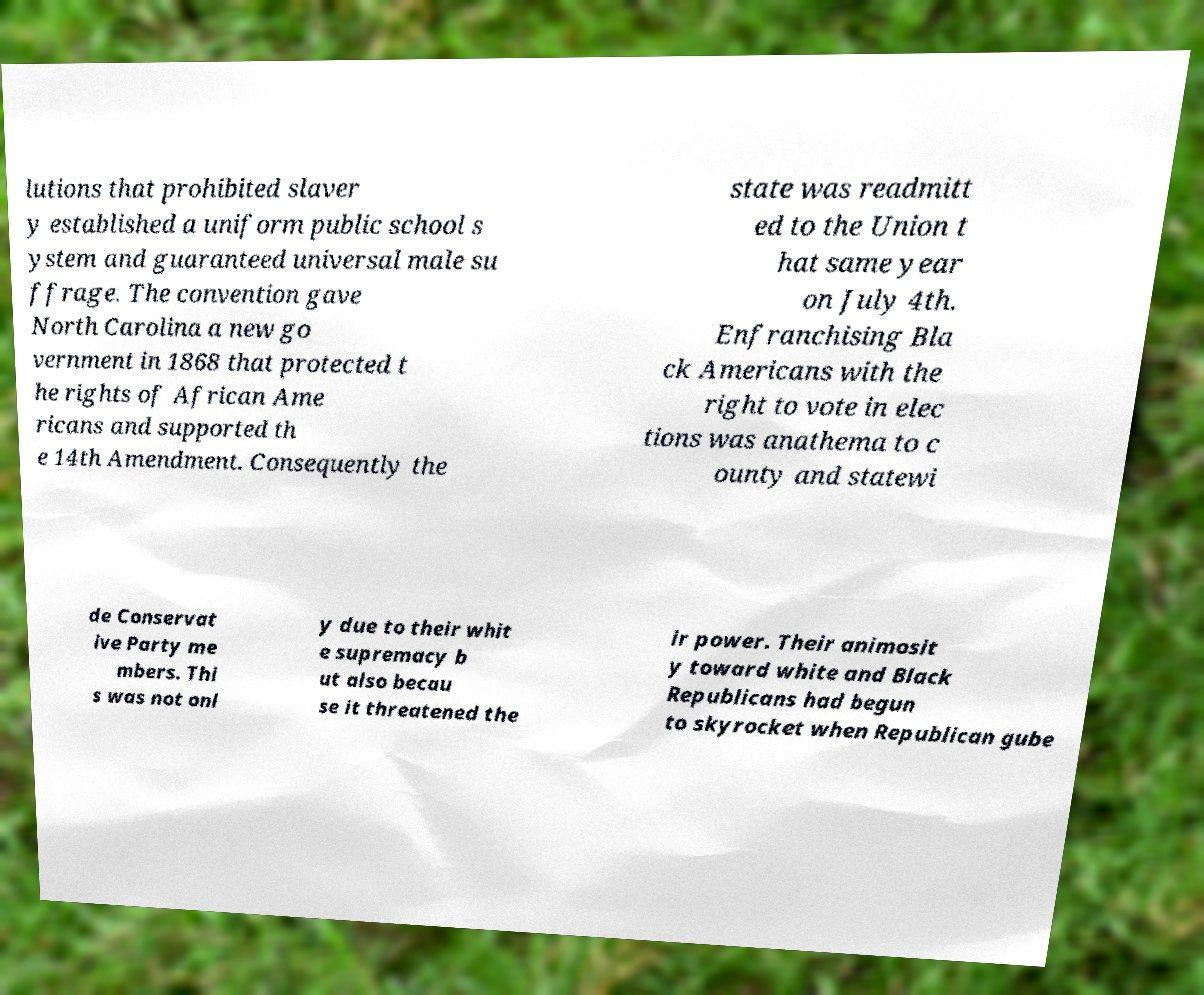There's text embedded in this image that I need extracted. Can you transcribe it verbatim? lutions that prohibited slaver y established a uniform public school s ystem and guaranteed universal male su ffrage. The convention gave North Carolina a new go vernment in 1868 that protected t he rights of African Ame ricans and supported th e 14th Amendment. Consequently the state was readmitt ed to the Union t hat same year on July 4th. Enfranchising Bla ck Americans with the right to vote in elec tions was anathema to c ounty and statewi de Conservat ive Party me mbers. Thi s was not onl y due to their whit e supremacy b ut also becau se it threatened the ir power. Their animosit y toward white and Black Republicans had begun to skyrocket when Republican gube 